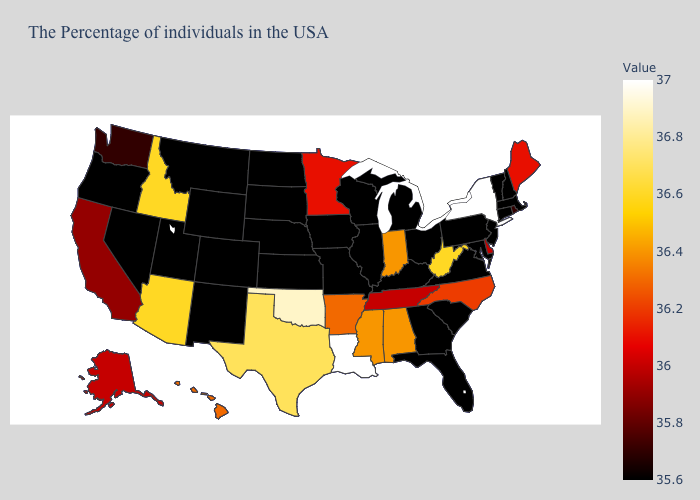Which states hav the highest value in the MidWest?
Write a very short answer. Indiana. Which states have the lowest value in the West?
Be succinct. Wyoming, Colorado, New Mexico, Utah, Montana, Nevada, Oregon. Does Georgia have the lowest value in the South?
Keep it brief. Yes. Which states have the lowest value in the USA?
Give a very brief answer. Massachusetts, New Hampshire, Vermont, Connecticut, New Jersey, Maryland, Pennsylvania, Virginia, South Carolina, Ohio, Florida, Georgia, Michigan, Kentucky, Wisconsin, Illinois, Missouri, Iowa, Kansas, Nebraska, South Dakota, North Dakota, Wyoming, Colorado, New Mexico, Utah, Montana, Nevada, Oregon. Does Maryland have the lowest value in the South?
Concise answer only. Yes. 